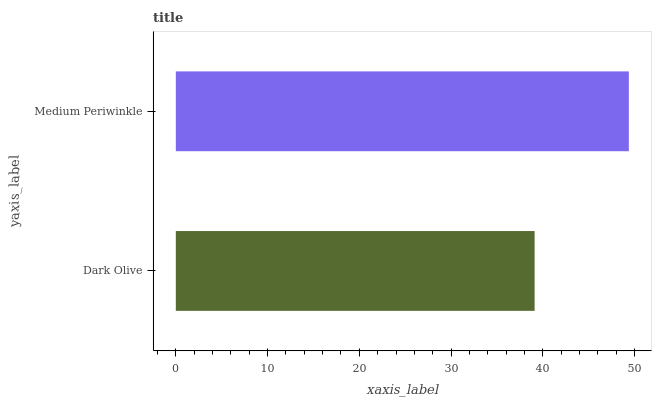Is Dark Olive the minimum?
Answer yes or no. Yes. Is Medium Periwinkle the maximum?
Answer yes or no. Yes. Is Medium Periwinkle the minimum?
Answer yes or no. No. Is Medium Periwinkle greater than Dark Olive?
Answer yes or no. Yes. Is Dark Olive less than Medium Periwinkle?
Answer yes or no. Yes. Is Dark Olive greater than Medium Periwinkle?
Answer yes or no. No. Is Medium Periwinkle less than Dark Olive?
Answer yes or no. No. Is Medium Periwinkle the high median?
Answer yes or no. Yes. Is Dark Olive the low median?
Answer yes or no. Yes. Is Dark Olive the high median?
Answer yes or no. No. Is Medium Periwinkle the low median?
Answer yes or no. No. 